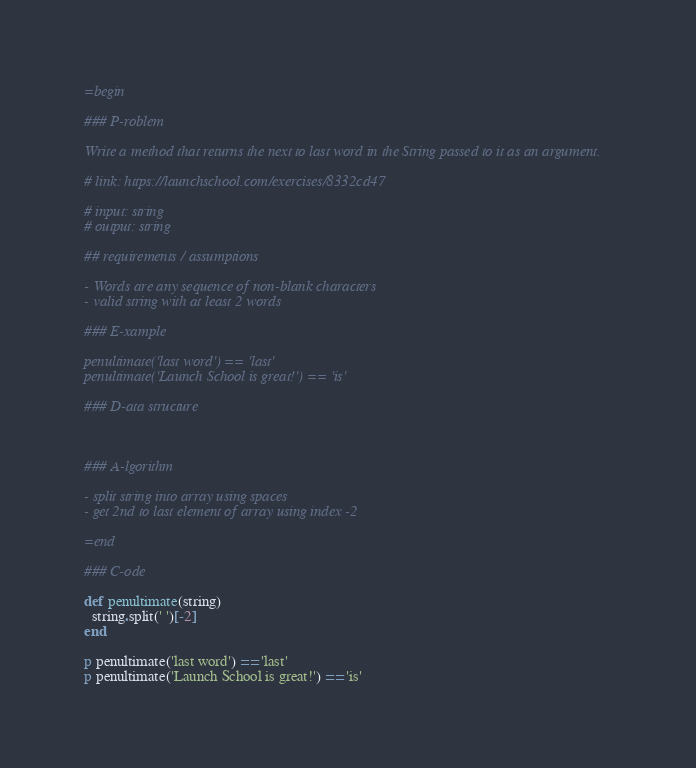Convert code to text. <code><loc_0><loc_0><loc_500><loc_500><_Ruby_>=begin

### P-roblem

Write a method that returns the next to last word in the String passed to it as an argument.

# link: https://launchschool.com/exercises/8332cd47

# input: string
# output: string

## requirements / assumptions

- Words are any sequence of non-blank characters
- valid string with at least 2 words

### E-xample

penultimate('last word') == 'last'
penultimate('Launch School is great!') == 'is'

### D-ata structure



### A-lgorithm

- split string into array using spaces
- get 2nd to last element of array using index -2

=end

### C-ode

def penultimate(string)
  string.split(' ')[-2]
end

p penultimate('last word') == 'last'
p penultimate('Launch School is great!') == 'is'
</code> 